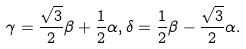<formula> <loc_0><loc_0><loc_500><loc_500>\gamma = \frac { \sqrt { 3 } } { 2 } \beta + \frac { 1 } { 2 } \alpha , \delta = \frac { 1 } { 2 } \beta - \frac { \sqrt { 3 } } { 2 } \alpha .</formula> 